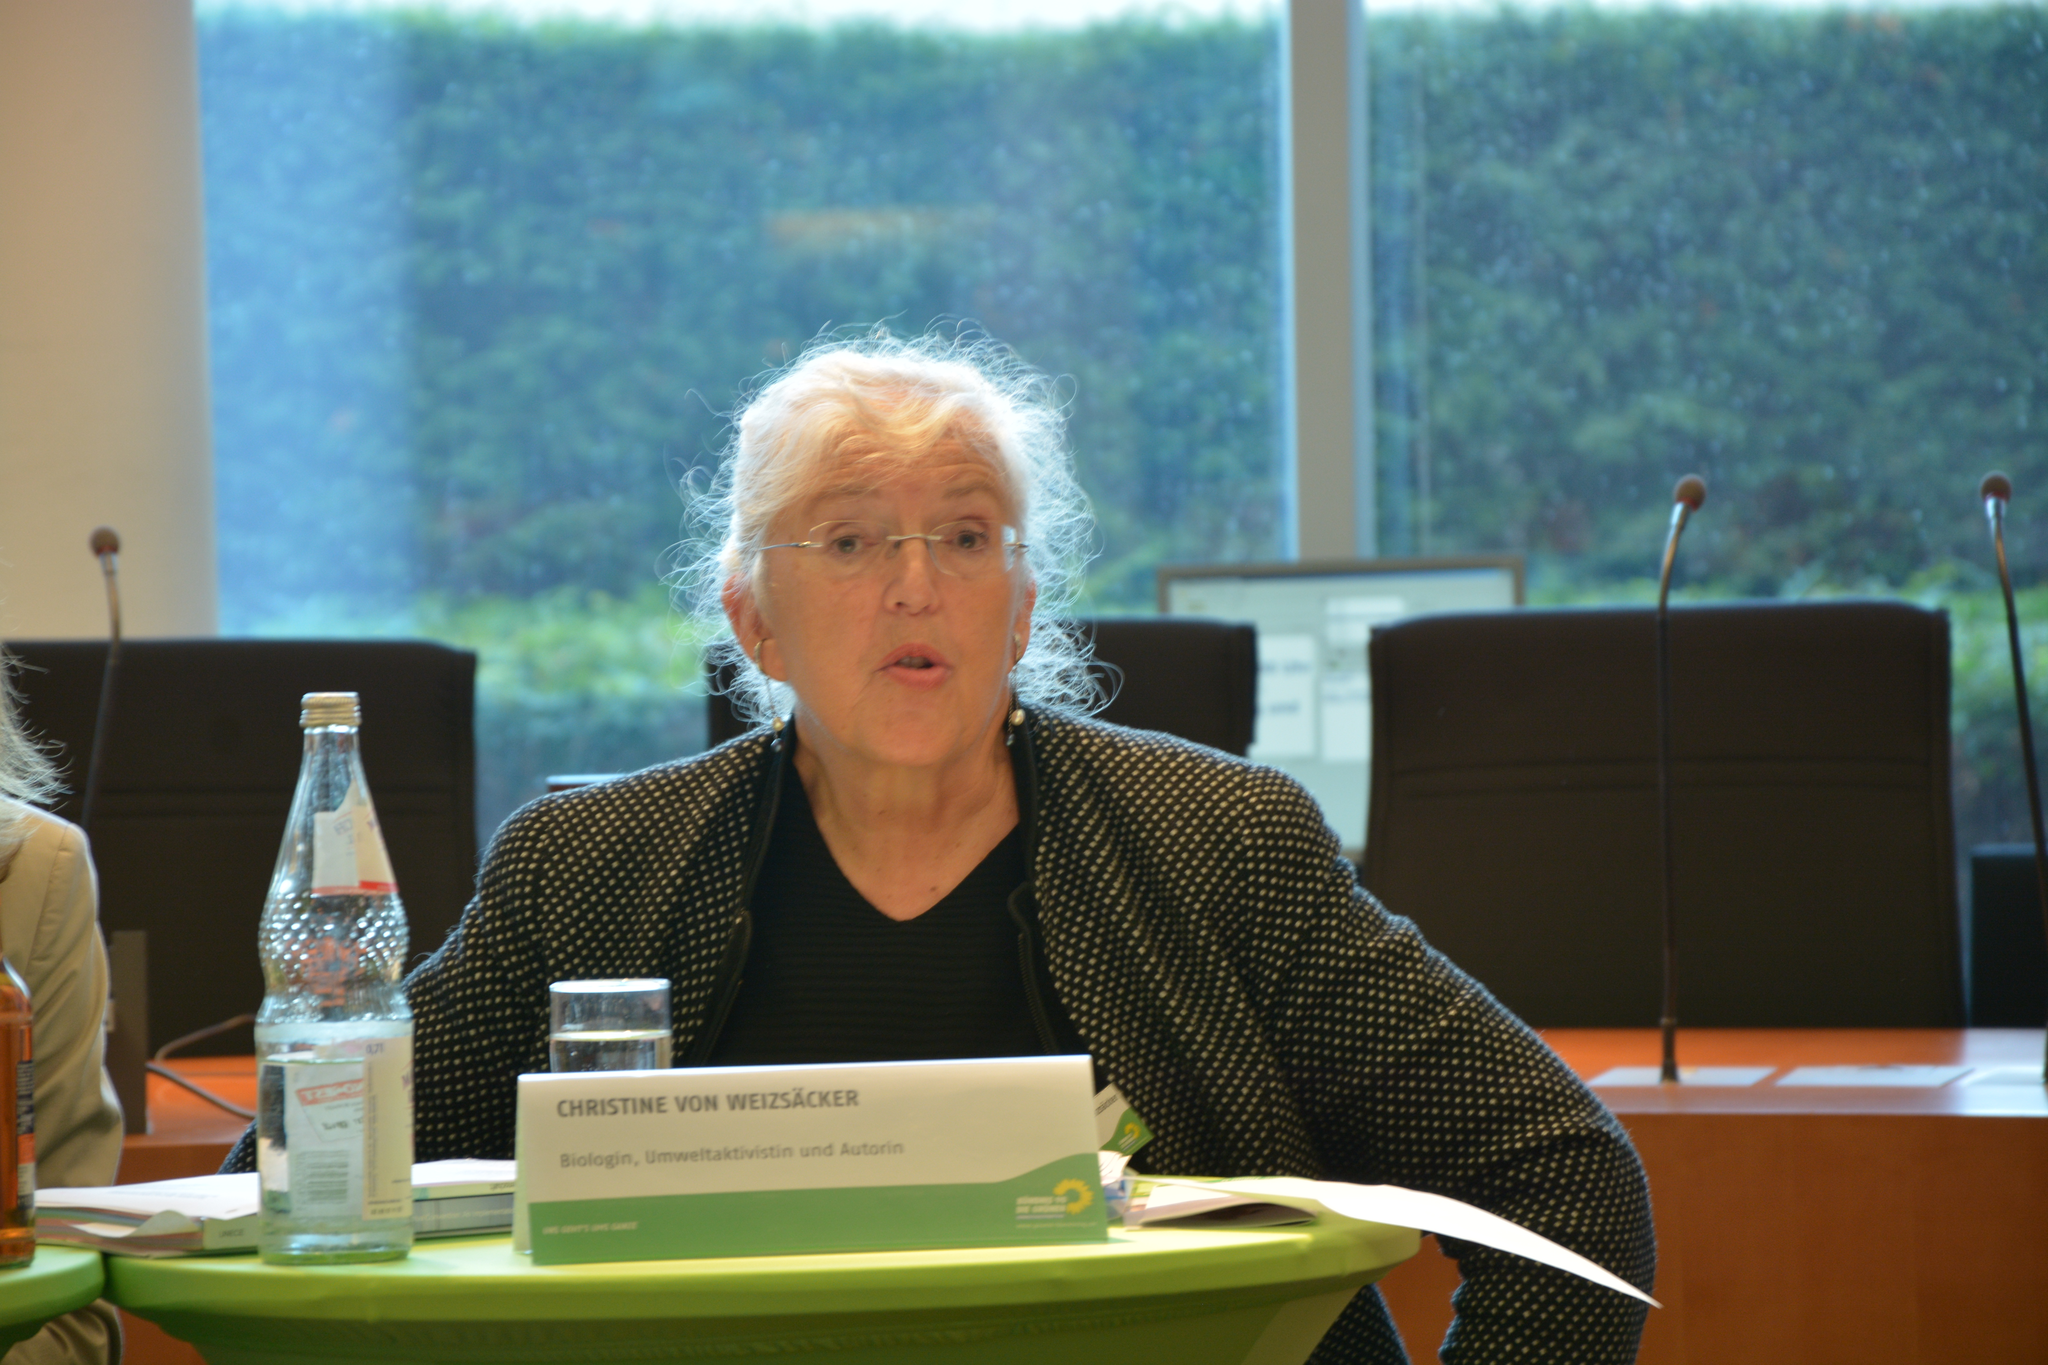<image>
Summarize the visual content of the image. A woman sits behind a table and a name plate that reads "Christine Von Weizsacker" 